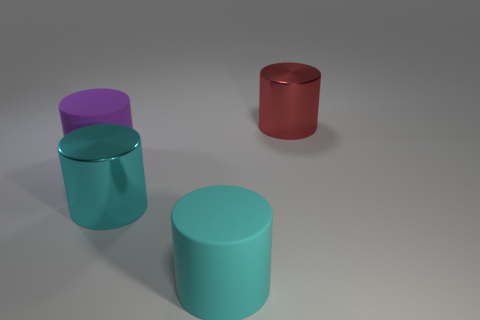Add 2 red things. How many objects exist? 6 Subtract all red cylinders. How many cylinders are left? 3 Subtract all large cyan rubber cylinders. How many cylinders are left? 3 Subtract 2 cylinders. How many cylinders are left? 2 Subtract all blue blocks. How many brown cylinders are left? 0 Add 4 small brown metallic cubes. How many small brown metallic cubes exist? 4 Subtract 0 brown cubes. How many objects are left? 4 Subtract all blue cylinders. Subtract all brown cubes. How many cylinders are left? 4 Subtract all cyan shiny cylinders. Subtract all large blue metallic blocks. How many objects are left? 3 Add 1 red things. How many red things are left? 2 